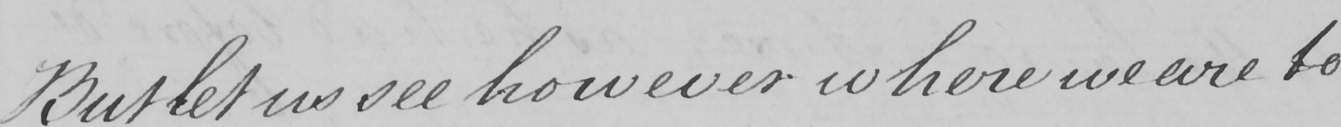What is written in this line of handwriting? But let us see however where we are to 